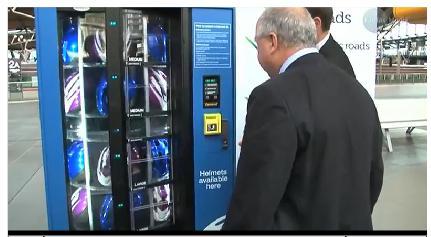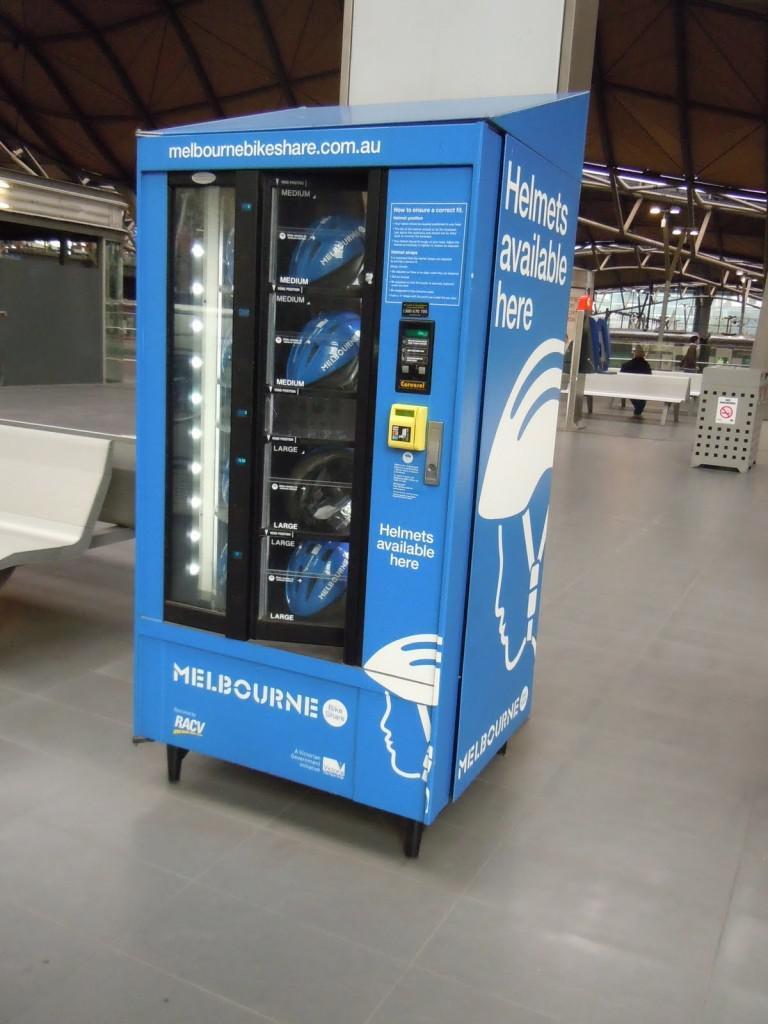The first image is the image on the left, the second image is the image on the right. Given the left and right images, does the statement "There is a at least one person in the image on the left." hold true? Answer yes or no. Yes. 